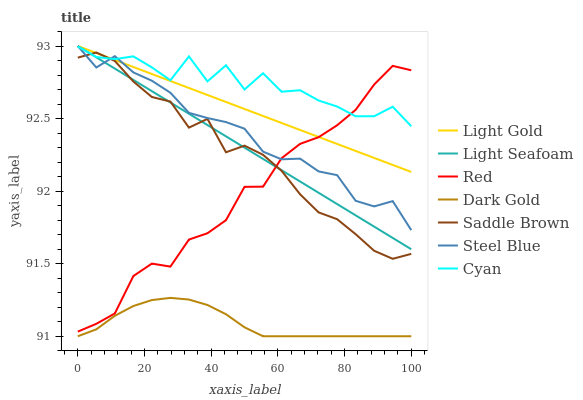Does Dark Gold have the minimum area under the curve?
Answer yes or no. Yes. Does Cyan have the maximum area under the curve?
Answer yes or no. Yes. Does Steel Blue have the minimum area under the curve?
Answer yes or no. No. Does Steel Blue have the maximum area under the curve?
Answer yes or no. No. Is Light Gold the smoothest?
Answer yes or no. Yes. Is Cyan the roughest?
Answer yes or no. Yes. Is Steel Blue the smoothest?
Answer yes or no. No. Is Steel Blue the roughest?
Answer yes or no. No. Does Steel Blue have the lowest value?
Answer yes or no. No. Does Cyan have the highest value?
Answer yes or no. No. Is Dark Gold less than Light Seafoam?
Answer yes or no. Yes. Is Cyan greater than Dark Gold?
Answer yes or no. Yes. Does Dark Gold intersect Light Seafoam?
Answer yes or no. No. 